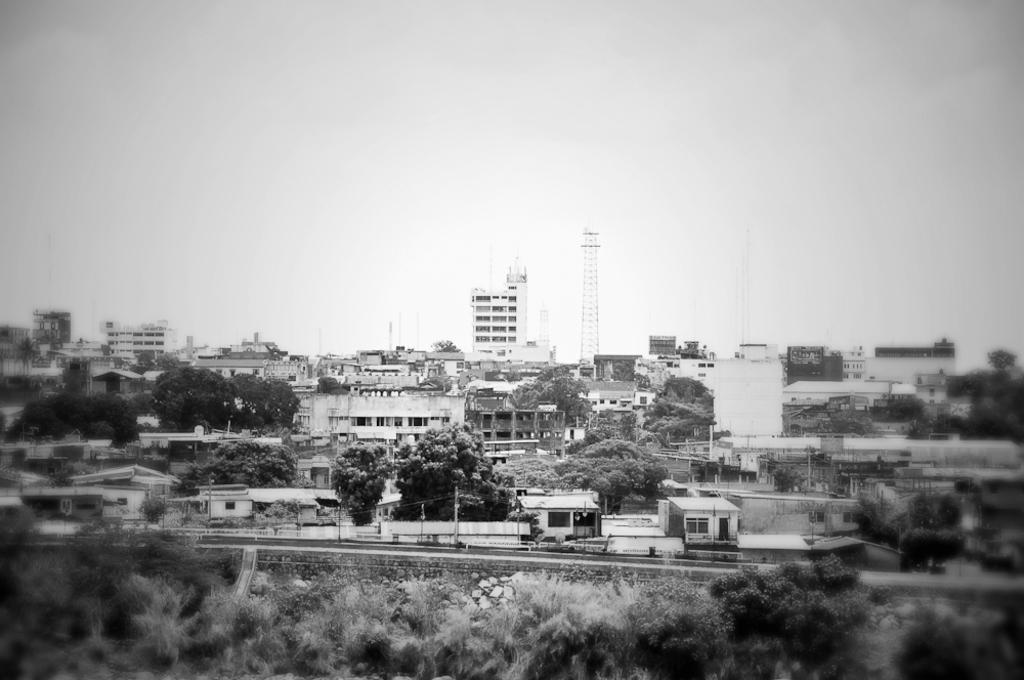What type of structures are present in the image? There are buildings in the image. What other natural elements can be seen in the image? There are trees in the image. What is the main feature in the middle of the image? There is a tower in the middle of the image. What is visible in the background of the image? The sky is visible in the background of the image. What is the color scheme of the image? The image is black and white. Can you tell me how many pickles are on the tower in the image? There are no pickles present in the image; it features buildings, trees, and a tower. What type of club is the stranger holding in the image? There is no stranger or club present in the image. 